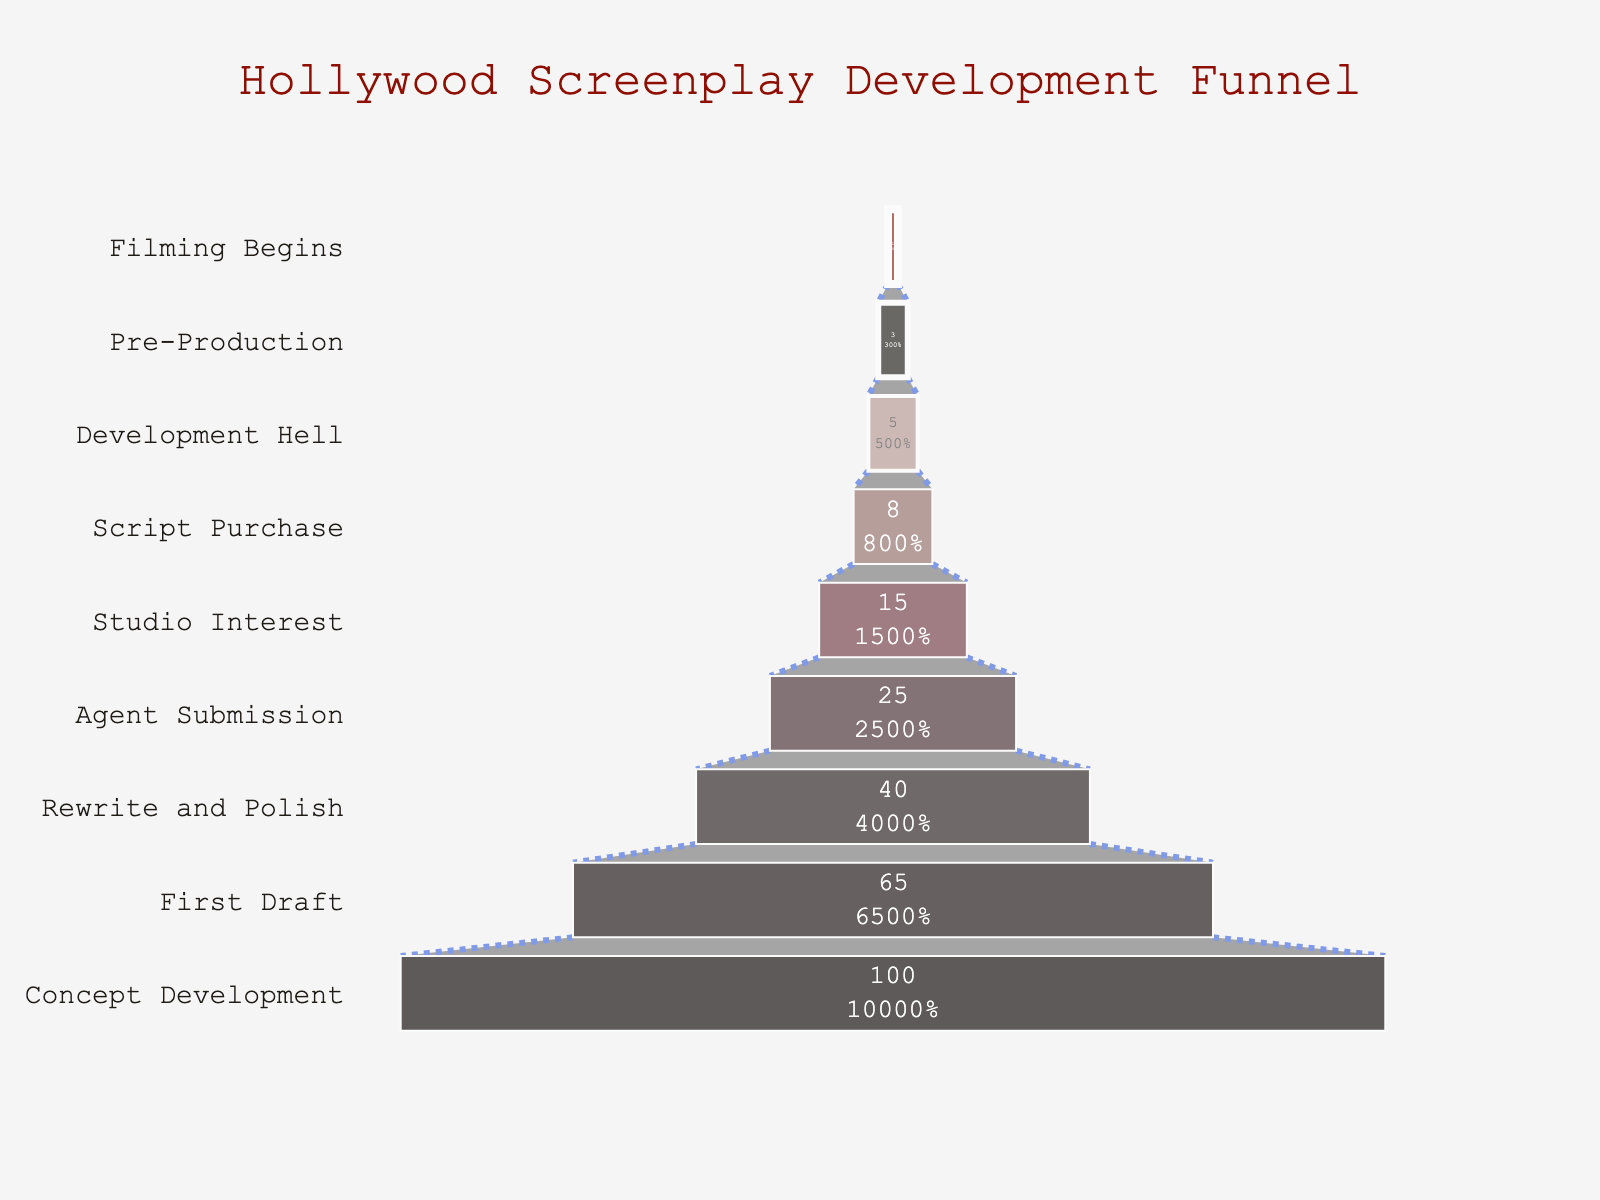What's the title of the chart? The title of the chart is displayed at the top. It reads "Hollywood Screenplay Development Funnel".
Answer: Hollywood Screenplay Development Funnel What percentage of scripts make it from First Draft to Rewrite and Polish? To determine the percentage of scripts that move from First Draft (65%) to Rewrite and Polish (40%), we look at the differences in percentages between these stages.
Answer: 40% What is the difference in percentage between Script Purchase and Studio Interest stages? The percentage for Script Purchase is 8%, and for Studio Interest is 15%. The difference is calculated as 15% - 8% = 7%.
Answer: 7% Which stage has the highest percentage of scripts? The stage with the highest percentage is at the top of the funnel. The "Concept Development" stage shows a percentage of 100%.
Answer: Concept Development At which stage does the percentage of scripts drop below 10%? The percentage drops below 10% at the "Script Purchase" stage, which has 8%.
Answer: Script Purchase How many stages are there in total in the funnel? The chart lists all stages from Concept Development to Filming Begins. Counting these, there are 9 stages.
Answer: 9 Between which two stages is the highest percentage drop observed? The largest drop in percentage is between the Concept Development (100%) and the First Draft (65%) stages. The difference is 35%.
Answer: Concept Development and First Draft What percentage of scripts progress from Development Hell to Pre-Production? The percentage at Development Hell is 5%, and at Pre-Production it is 3%. Therefore, 3% of scripts progress from Development Hell to Pre-Production.
Answer: 3% Which stage directly follows Agent Submission in the funnel? The stage that immediately follows Agent Submission (25%) in the funnel is Studio Interest (15%).
Answer: Studio Interest What percentage of scripts enter the Filming Begins stage? The final stage listed in the funnel is Filming Begins, with a percentage of 1%.
Answer: 1% 